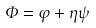Convert formula to latex. <formula><loc_0><loc_0><loc_500><loc_500>\Phi = \varphi + \eta \psi</formula> 